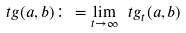Convert formula to latex. <formula><loc_0><loc_0><loc_500><loc_500>\ t g ( a , b ) \colon = \lim _ { t \to \infty } \ t g _ { t } ( a , b )</formula> 